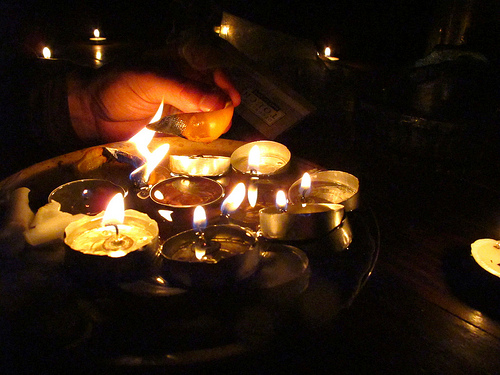<image>
Is there a candle to the left of the plate? No. The candle is not to the left of the plate. From this viewpoint, they have a different horizontal relationship. 